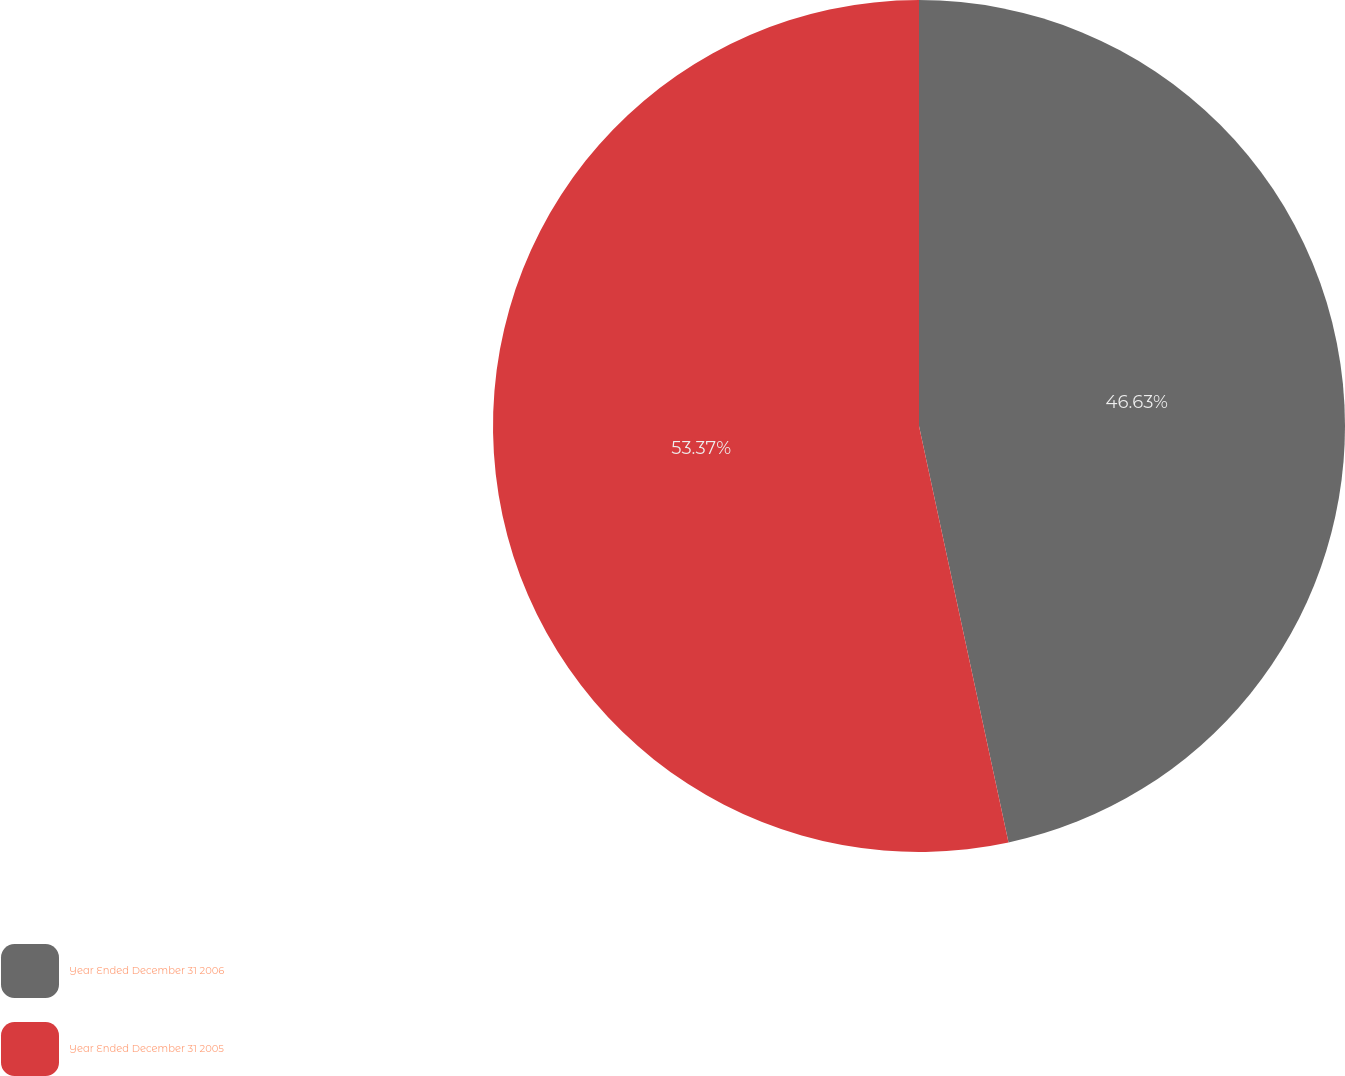<chart> <loc_0><loc_0><loc_500><loc_500><pie_chart><fcel>Year Ended December 31 2006<fcel>Year Ended December 31 2005<nl><fcel>46.63%<fcel>53.37%<nl></chart> 